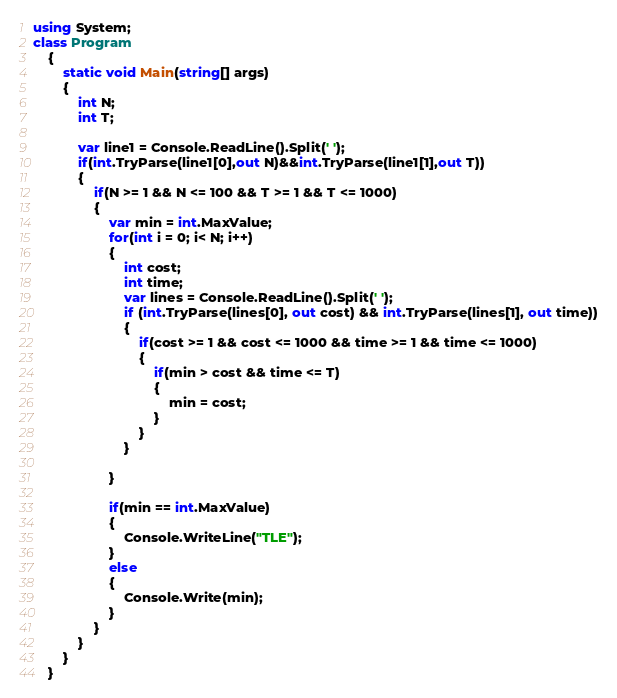<code> <loc_0><loc_0><loc_500><loc_500><_C#_>using System; 
class Program
    {
        static void Main(string[] args)
        {
            int N;
            int T;

            var line1 = Console.ReadLine().Split(' ');
            if(int.TryParse(line1[0],out N)&&int.TryParse(line1[1],out T))
            {
                if(N >= 1 && N <= 100 && T >= 1 && T <= 1000)
                {
                    var min = int.MaxValue;
                    for(int i = 0; i< N; i++)
                    {
                        int cost;
                        int time;
                        var lines = Console.ReadLine().Split(' ');
                        if (int.TryParse(lines[0], out cost) && int.TryParse(lines[1], out time))
                        { 
                            if(cost >= 1 && cost <= 1000 && time >= 1 && time <= 1000)
                            {
                                if(min > cost && time <= T)
                                {
                                    min = cost;
                                }
                            }
                        }

                    }

                    if(min == int.MaxValue)
                    {
                        Console.WriteLine("TLE");
                    }
                    else
                    {
                        Console.Write(min);
                    }
                }
            }
        }
    }</code> 